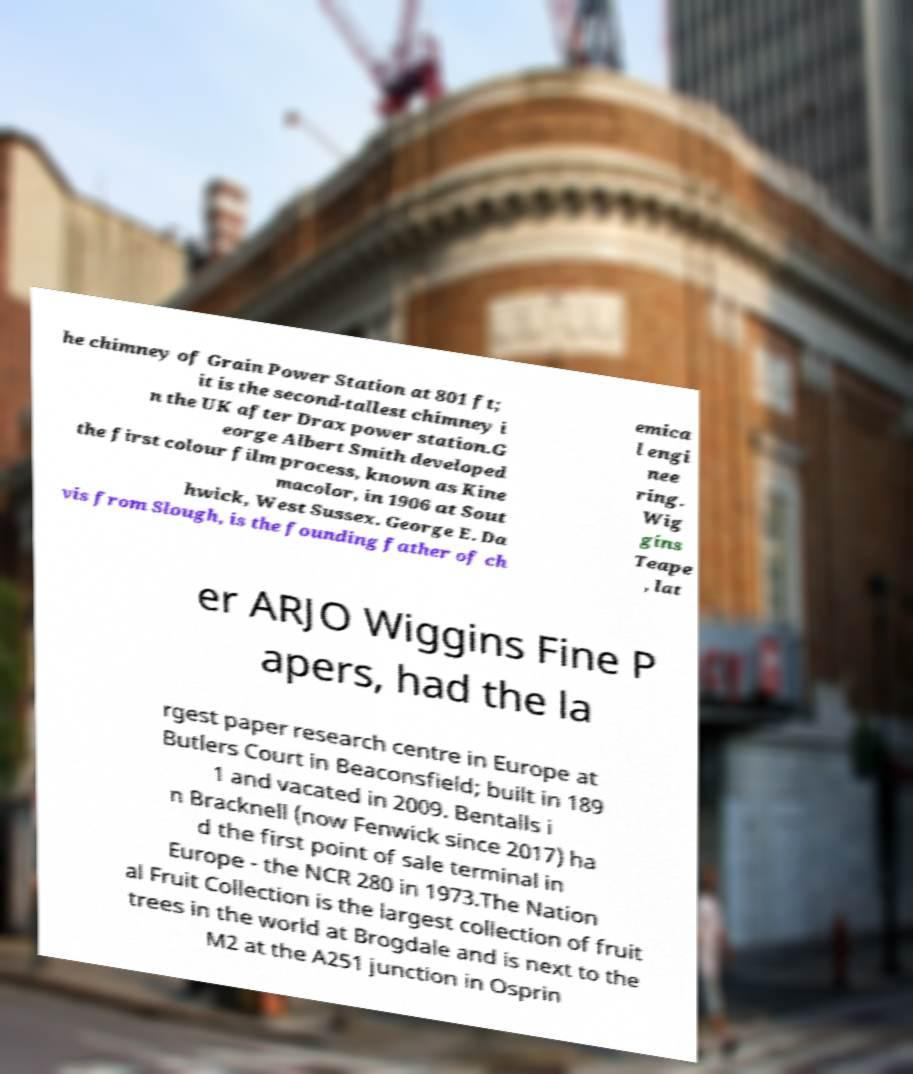What messages or text are displayed in this image? I need them in a readable, typed format. he chimney of Grain Power Station at 801 ft; it is the second-tallest chimney i n the UK after Drax power station.G eorge Albert Smith developed the first colour film process, known as Kine macolor, in 1906 at Sout hwick, West Sussex. George E. Da vis from Slough, is the founding father of ch emica l engi nee ring. Wig gins Teape , lat er ARJO Wiggins Fine P apers, had the la rgest paper research centre in Europe at Butlers Court in Beaconsfield; built in 189 1 and vacated in 2009. Bentalls i n Bracknell (now Fenwick since 2017) ha d the first point of sale terminal in Europe - the NCR 280 in 1973.The Nation al Fruit Collection is the largest collection of fruit trees in the world at Brogdale and is next to the M2 at the A251 junction in Osprin 